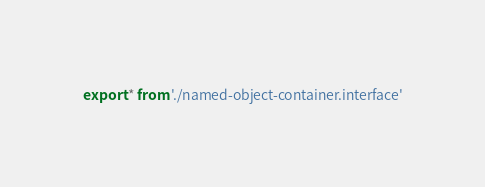<code> <loc_0><loc_0><loc_500><loc_500><_TypeScript_>export * from './named-object-container.interface'
</code> 